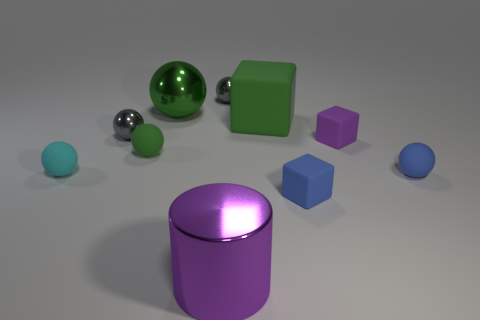Subtract all big green matte blocks. How many blocks are left? 2 Subtract all gray spheres. How many spheres are left? 4 Subtract all blocks. How many objects are left? 7 Subtract 5 spheres. How many spheres are left? 1 Subtract all green blocks. How many green cylinders are left? 0 Subtract all tiny purple objects. Subtract all large objects. How many objects are left? 6 Add 5 gray shiny things. How many gray shiny things are left? 7 Add 9 tiny blue rubber cylinders. How many tiny blue rubber cylinders exist? 9 Subtract 2 green balls. How many objects are left? 8 Subtract all blue cylinders. Subtract all yellow blocks. How many cylinders are left? 1 